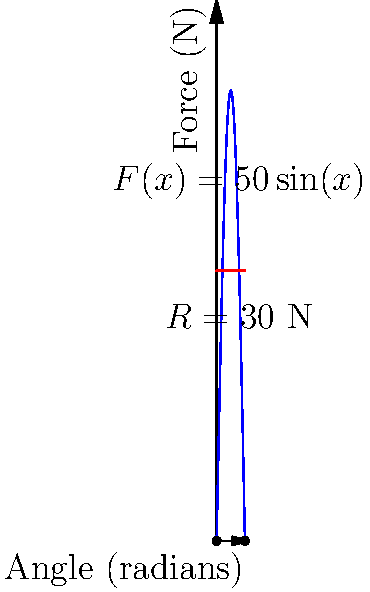A bicep curl exercise is performed where the force exerted by the bicep muscle varies with the angle of the elbow joint. The force $F(x)$ in Newtons is given by $F(x) = 50\sin(x)$, where $x$ is the angle in radians. The resistance force $R$ is constant at 30 N. If the movement starts at $x=0$ and ends at $x=\pi$ radians, calculate the total work done by the bicep muscle during this exercise. To solve this problem, we need to follow these steps:

1) The work done is calculated by integrating the net force over the displacement. In this case, we need to integrate the difference between the muscle force and the resistance force.

2) The net force is $F(x) - R = 50\sin(x) - 30$

3) Work is given by the integral:
   $$W = \int_{0}^{\pi} (F(x) - R) dx = \int_{0}^{\pi} (50\sin(x) - 30) dx$$

4) Let's solve this integral:
   $$W = [-50\cos(x) - 30x]_{0}^{\pi}$$

5) Evaluating at the limits:
   $$W = [-50\cos(\pi) - 30\pi] - [-50\cos(0) - 30(0)]$$
   $$W = [50 - 30\pi] - [-50]$$
   $$W = 100 - 30\pi$$

6) Calculate the final value:
   $$W \approx 5.73 \text{ J}$$

Therefore, the total work done by the bicep muscle during this exercise is approximately 5.73 Joules.
Answer: $100 - 30\pi \approx 5.73 \text{ J}$ 